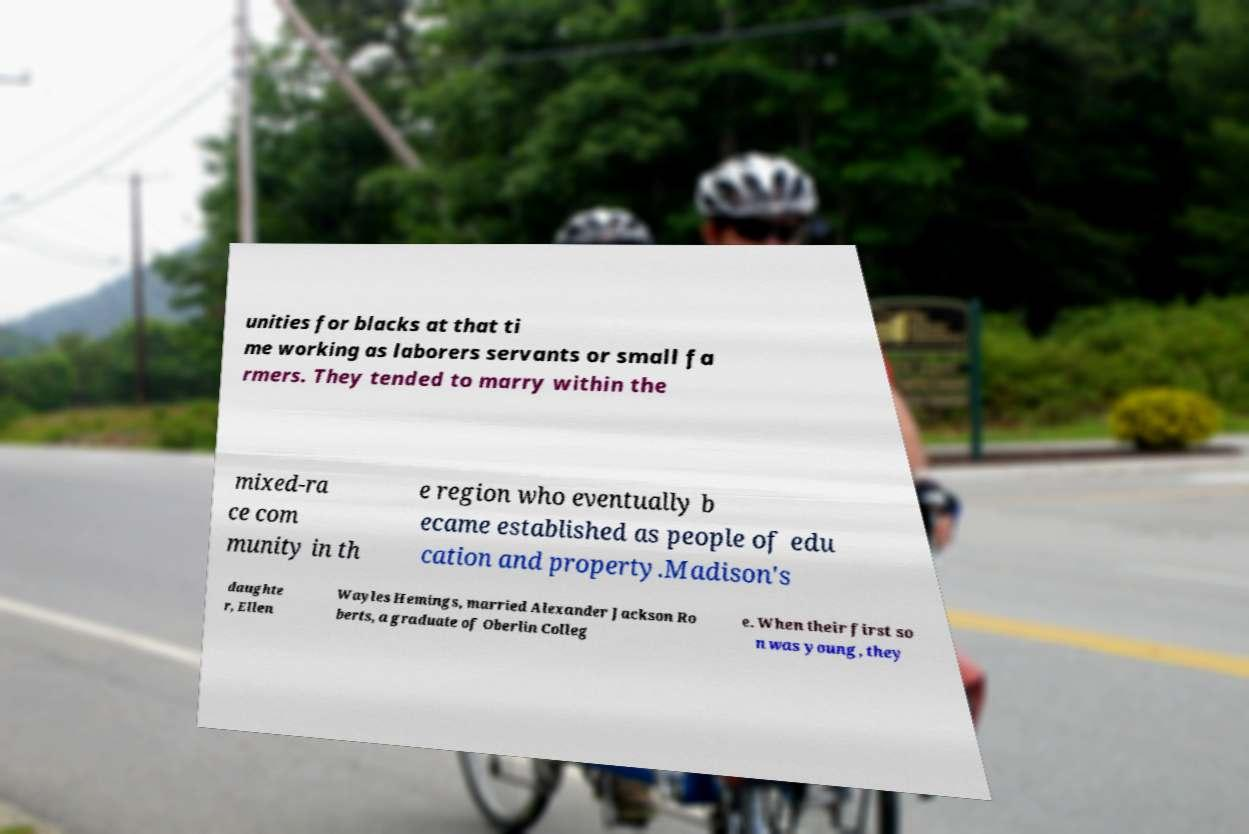There's text embedded in this image that I need extracted. Can you transcribe it verbatim? unities for blacks at that ti me working as laborers servants or small fa rmers. They tended to marry within the mixed-ra ce com munity in th e region who eventually b ecame established as people of edu cation and property.Madison's daughte r, Ellen Wayles Hemings, married Alexander Jackson Ro berts, a graduate of Oberlin Colleg e. When their first so n was young, they 